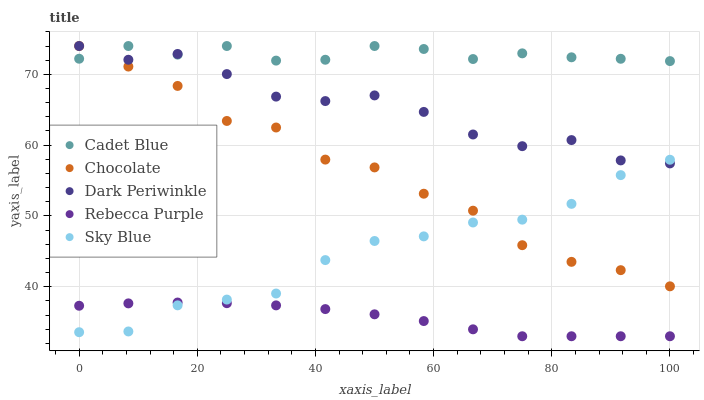Does Rebecca Purple have the minimum area under the curve?
Answer yes or no. Yes. Does Cadet Blue have the maximum area under the curve?
Answer yes or no. Yes. Does Dark Periwinkle have the minimum area under the curve?
Answer yes or no. No. Does Dark Periwinkle have the maximum area under the curve?
Answer yes or no. No. Is Rebecca Purple the smoothest?
Answer yes or no. Yes. Is Dark Periwinkle the roughest?
Answer yes or no. Yes. Is Cadet Blue the smoothest?
Answer yes or no. No. Is Cadet Blue the roughest?
Answer yes or no. No. Does Rebecca Purple have the lowest value?
Answer yes or no. Yes. Does Dark Periwinkle have the lowest value?
Answer yes or no. No. Does Chocolate have the highest value?
Answer yes or no. Yes. Does Rebecca Purple have the highest value?
Answer yes or no. No. Is Rebecca Purple less than Cadet Blue?
Answer yes or no. Yes. Is Cadet Blue greater than Sky Blue?
Answer yes or no. Yes. Does Sky Blue intersect Dark Periwinkle?
Answer yes or no. Yes. Is Sky Blue less than Dark Periwinkle?
Answer yes or no. No. Is Sky Blue greater than Dark Periwinkle?
Answer yes or no. No. Does Rebecca Purple intersect Cadet Blue?
Answer yes or no. No. 